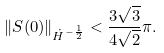Convert formula to latex. <formula><loc_0><loc_0><loc_500><loc_500>\| S ( 0 ) \| _ { \dot { H } ^ { - \frac { 1 } { 2 } } } < \frac { 3 \sqrt { 3 } } { 4 \sqrt { 2 } } \pi .</formula> 